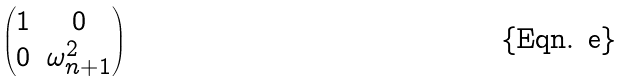Convert formula to latex. <formula><loc_0><loc_0><loc_500><loc_500>\begin{pmatrix} 1 & 0 \\ 0 & \omega _ { n + 1 } ^ { 2 } \end{pmatrix}</formula> 